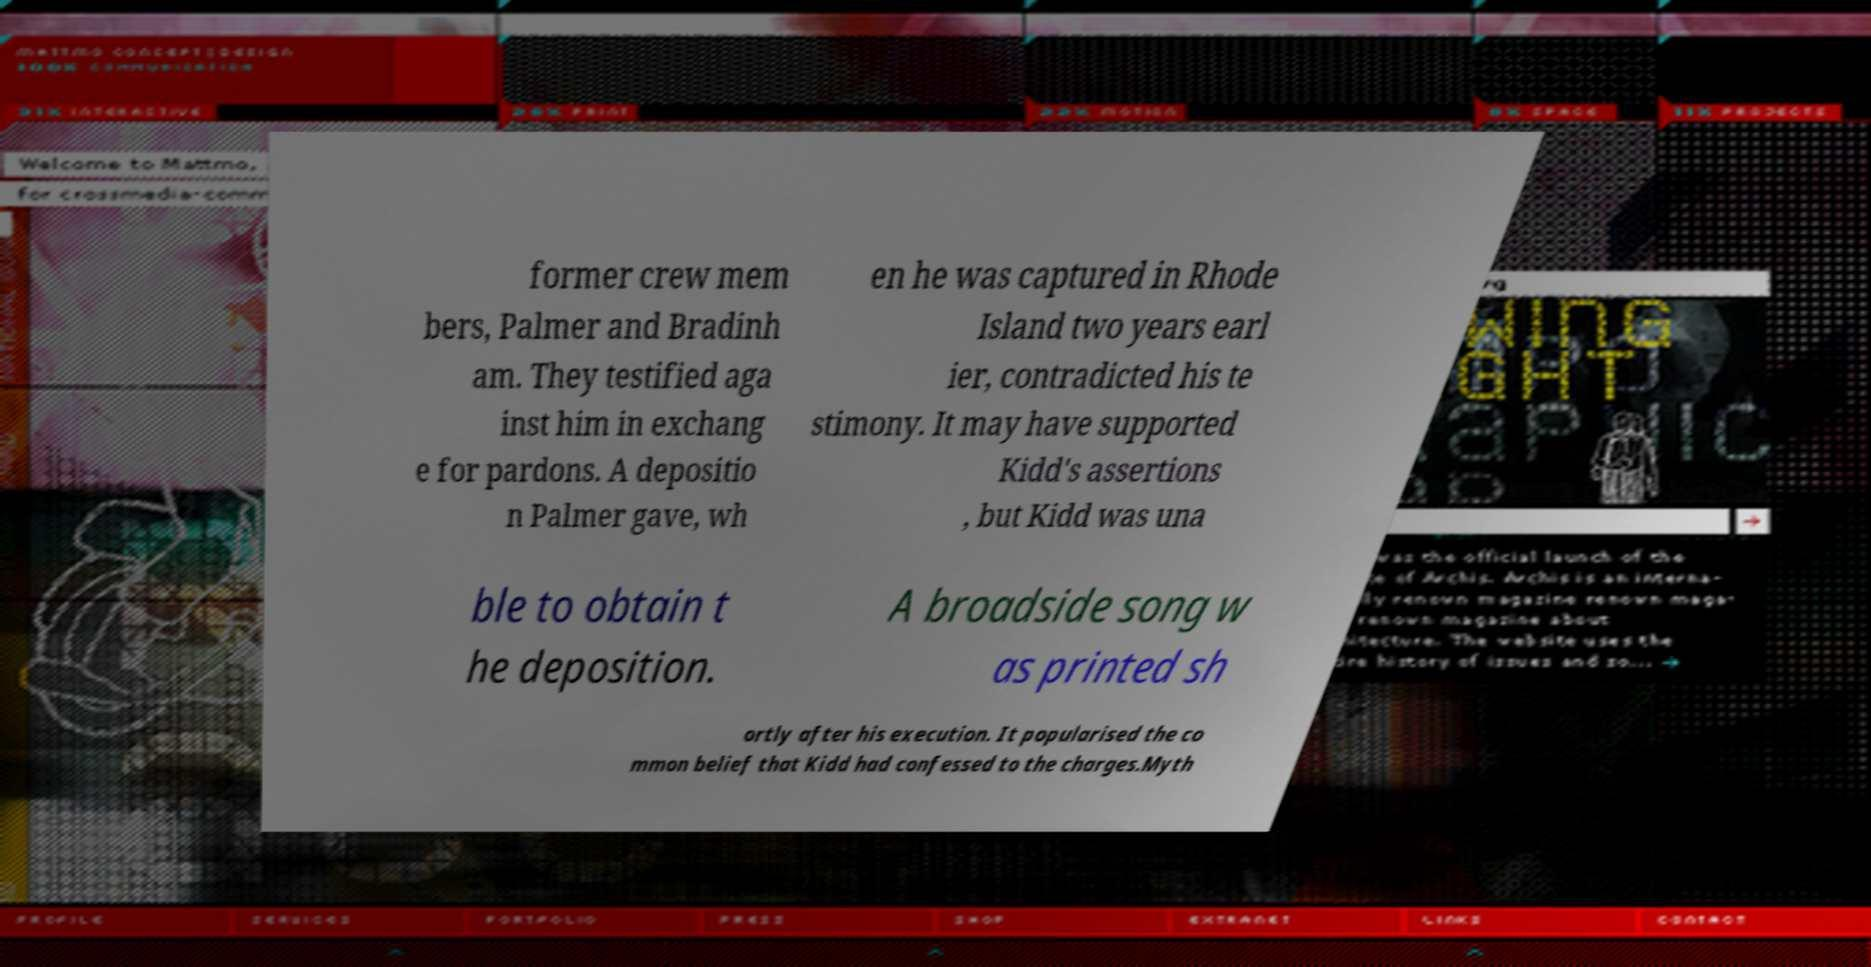Please read and relay the text visible in this image. What does it say? former crew mem bers, Palmer and Bradinh am. They testified aga inst him in exchang e for pardons. A depositio n Palmer gave, wh en he was captured in Rhode Island two years earl ier, contradicted his te stimony. It may have supported Kidd's assertions , but Kidd was una ble to obtain t he deposition. A broadside song w as printed sh ortly after his execution. It popularised the co mmon belief that Kidd had confessed to the charges.Myth 